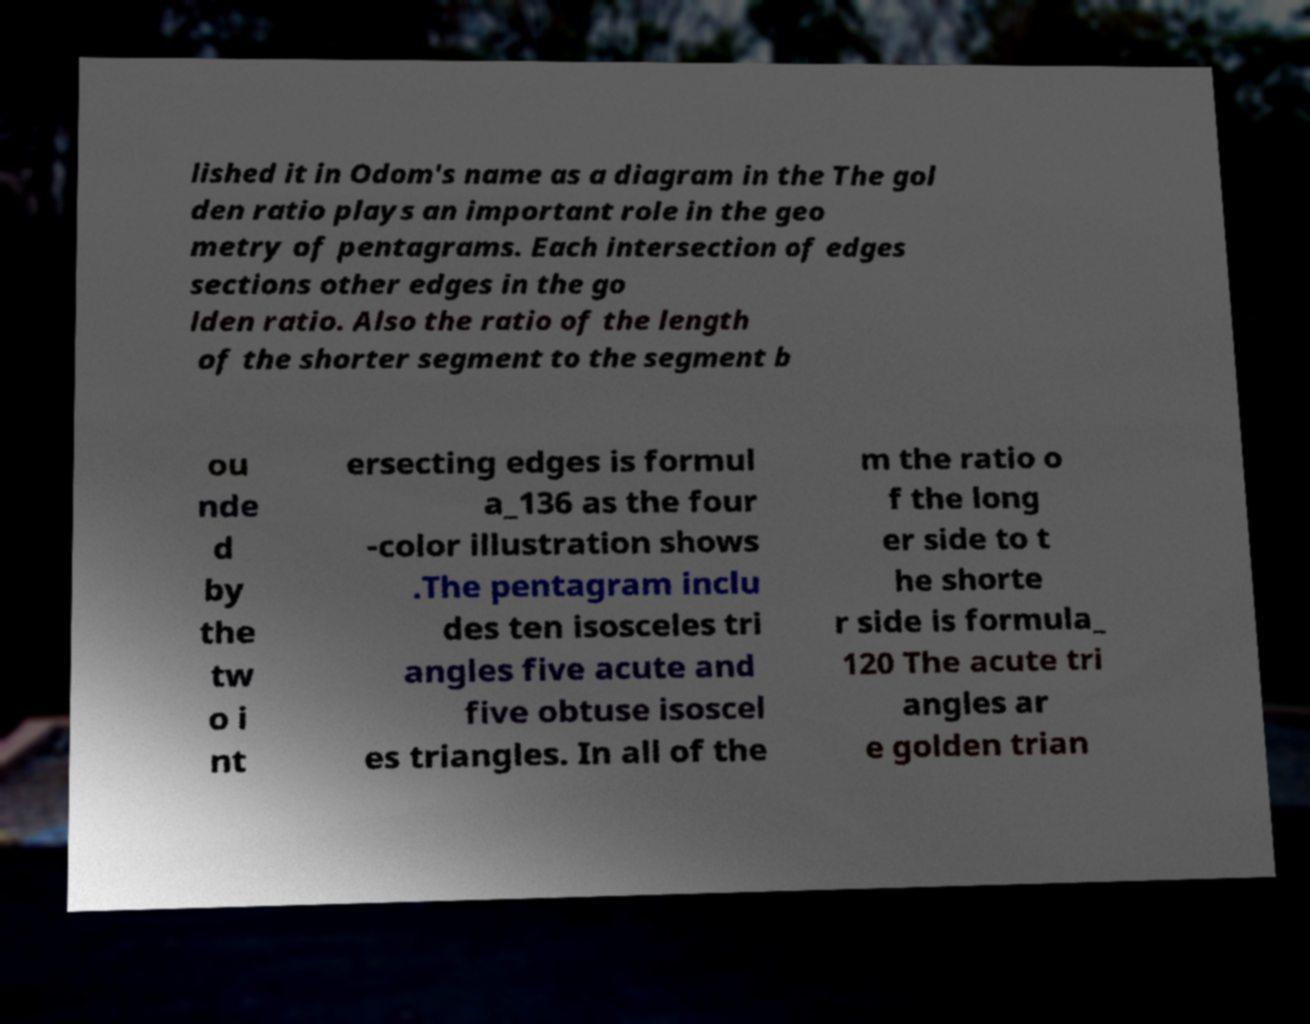There's text embedded in this image that I need extracted. Can you transcribe it verbatim? lished it in Odom's name as a diagram in the The gol den ratio plays an important role in the geo metry of pentagrams. Each intersection of edges sections other edges in the go lden ratio. Also the ratio of the length of the shorter segment to the segment b ou nde d by the tw o i nt ersecting edges is formul a_136 as the four -color illustration shows .The pentagram inclu des ten isosceles tri angles five acute and five obtuse isoscel es triangles. In all of the m the ratio o f the long er side to t he shorte r side is formula_ 120 The acute tri angles ar e golden trian 